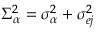Convert formula to latex. <formula><loc_0><loc_0><loc_500><loc_500>\Sigma _ { \alpha } ^ { 2 } = \sigma _ { \alpha } ^ { 2 } + \sigma _ { e j } ^ { 2 }</formula> 